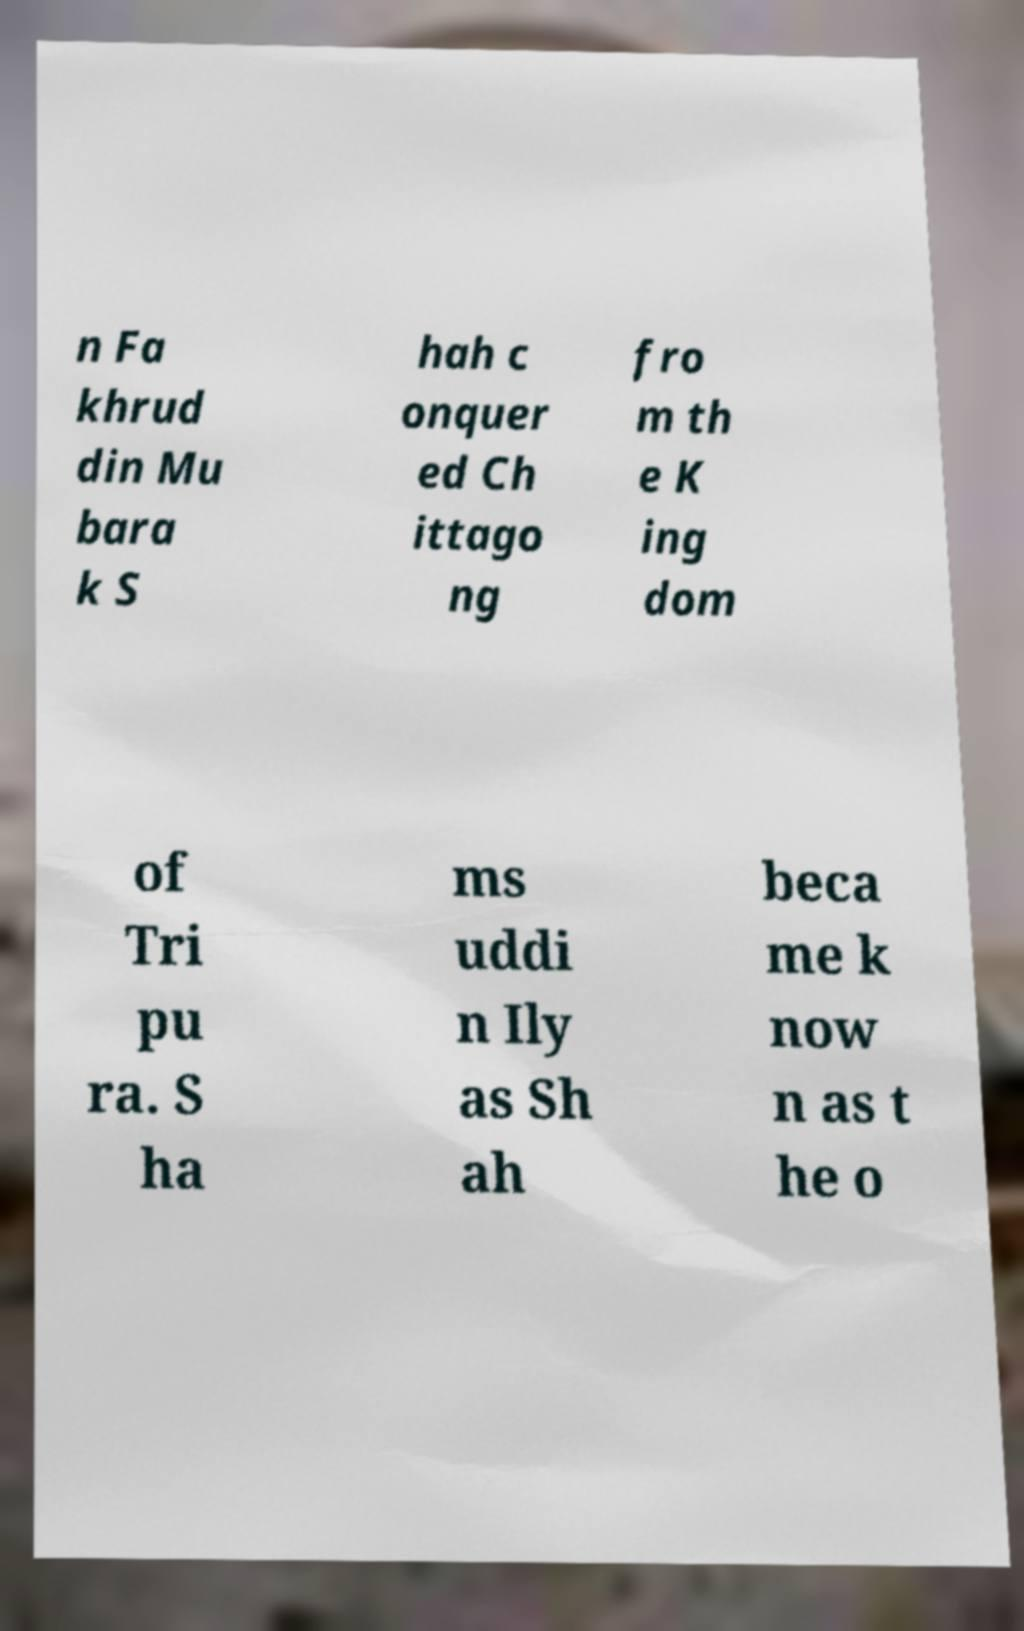Please identify and transcribe the text found in this image. n Fa khrud din Mu bara k S hah c onquer ed Ch ittago ng fro m th e K ing dom of Tri pu ra. S ha ms uddi n Ily as Sh ah beca me k now n as t he o 